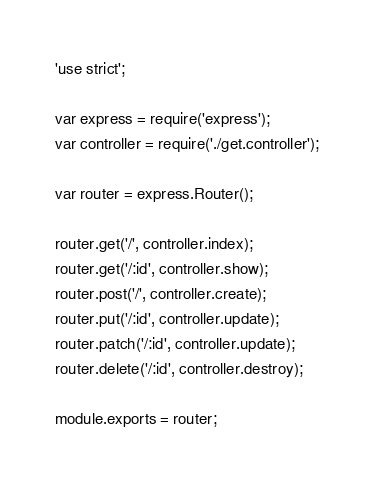<code> <loc_0><loc_0><loc_500><loc_500><_JavaScript_>'use strict';

var express = require('express');
var controller = require('./get.controller');

var router = express.Router();

router.get('/', controller.index);
router.get('/:id', controller.show);
router.post('/', controller.create);
router.put('/:id', controller.update);
router.patch('/:id', controller.update);
router.delete('/:id', controller.destroy);

module.exports = router;</code> 